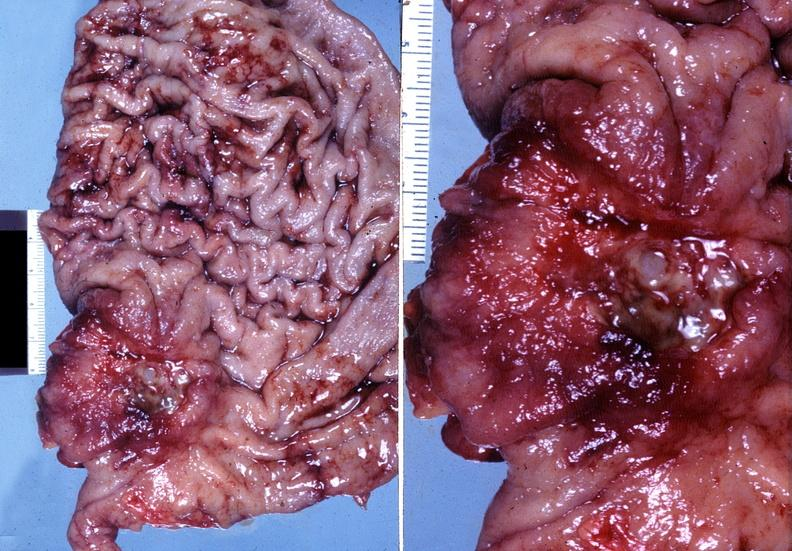where does this belong to?
Answer the question using a single word or phrase. Gastrointestinal system 